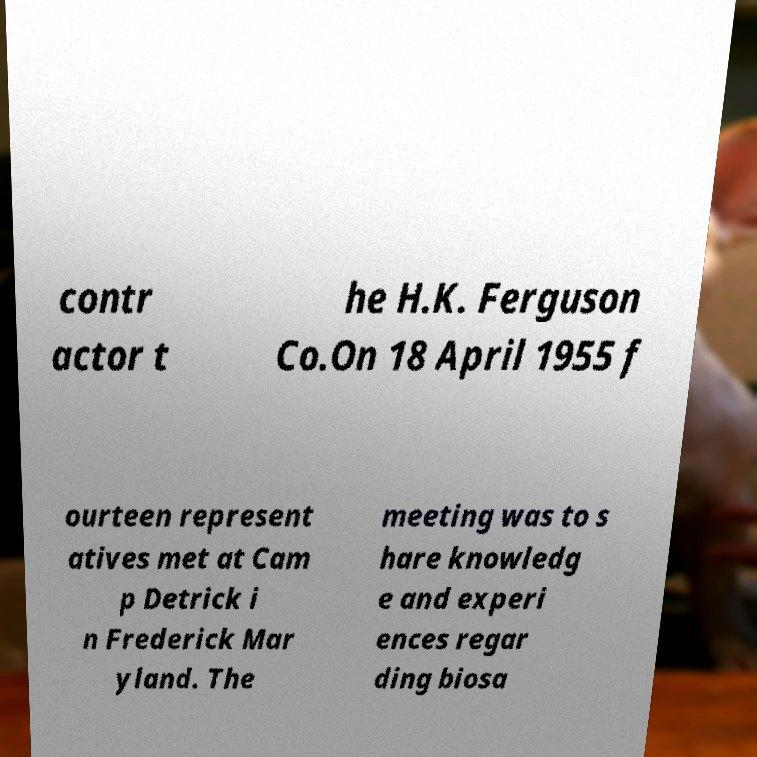Can you read and provide the text displayed in the image?This photo seems to have some interesting text. Can you extract and type it out for me? contr actor t he H.K. Ferguson Co.On 18 April 1955 f ourteen represent atives met at Cam p Detrick i n Frederick Mar yland. The meeting was to s hare knowledg e and experi ences regar ding biosa 